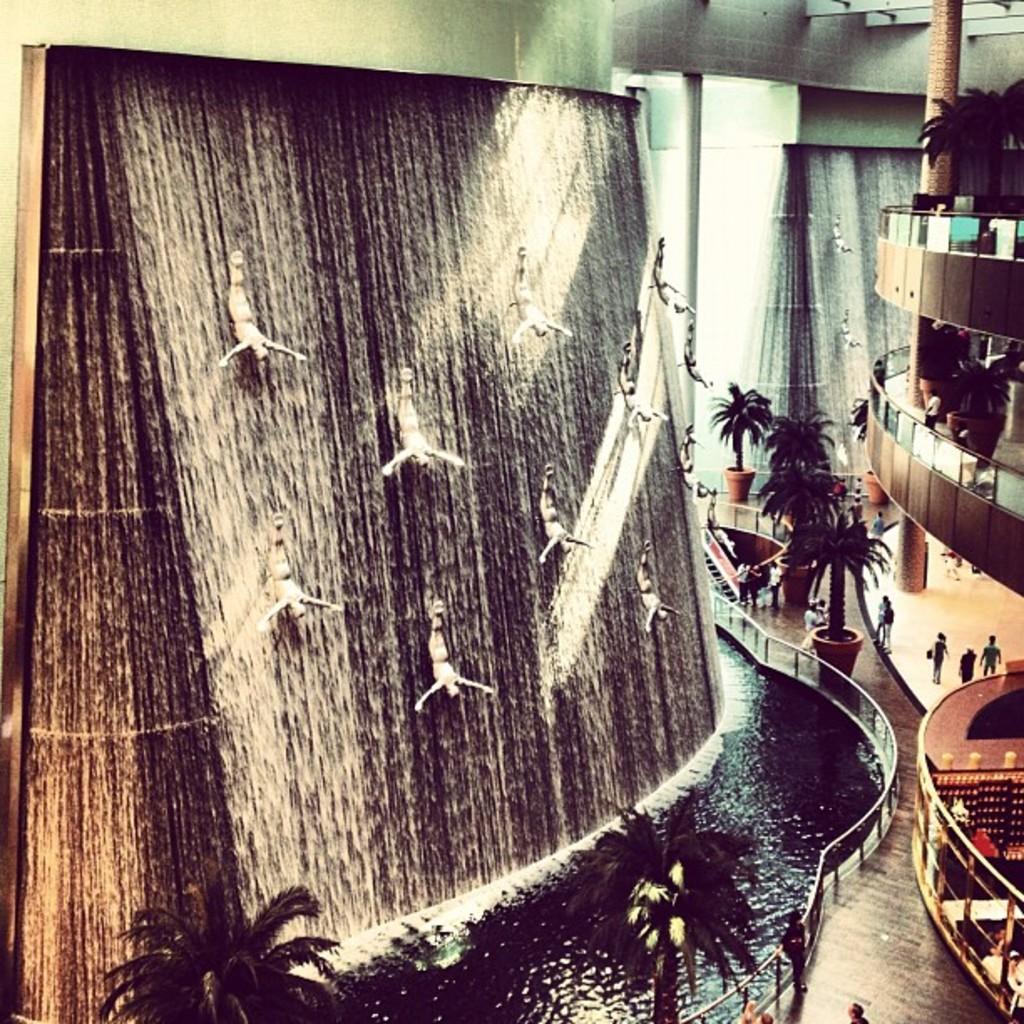Please provide a concise description of this image. In this image on the left side it might be a fountain and also there are some trees and some statues. On the right side there is a railing and some trees and some persons are walking, and in the background there is a wall. At the bottom there is floor. 